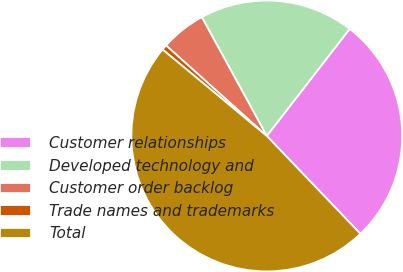<chart> <loc_0><loc_0><loc_500><loc_500><pie_chart><fcel>Customer relationships<fcel>Developed technology and<fcel>Customer order backlog<fcel>Trade names and trademarks<fcel>Total<nl><fcel>27.37%<fcel>18.45%<fcel>5.38%<fcel>0.63%<fcel>48.17%<nl></chart> 